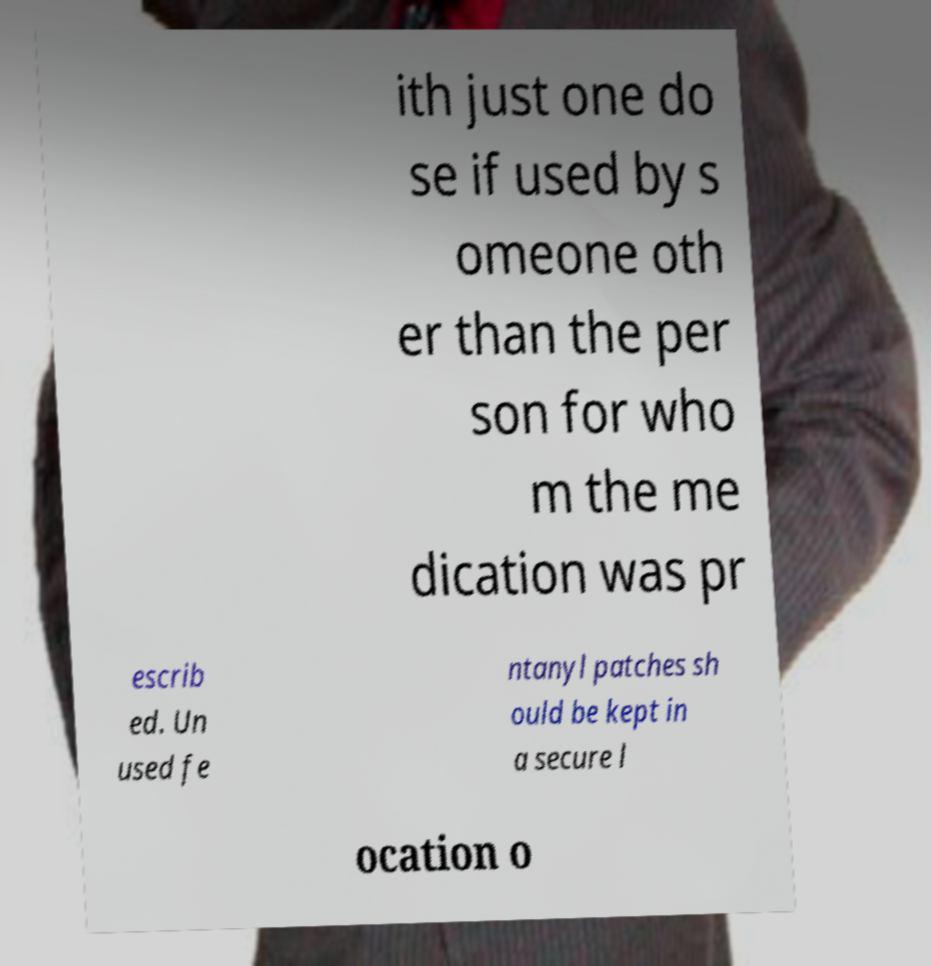Can you read and provide the text displayed in the image?This photo seems to have some interesting text. Can you extract and type it out for me? ith just one do se if used by s omeone oth er than the per son for who m the me dication was pr escrib ed. Un used fe ntanyl patches sh ould be kept in a secure l ocation o 